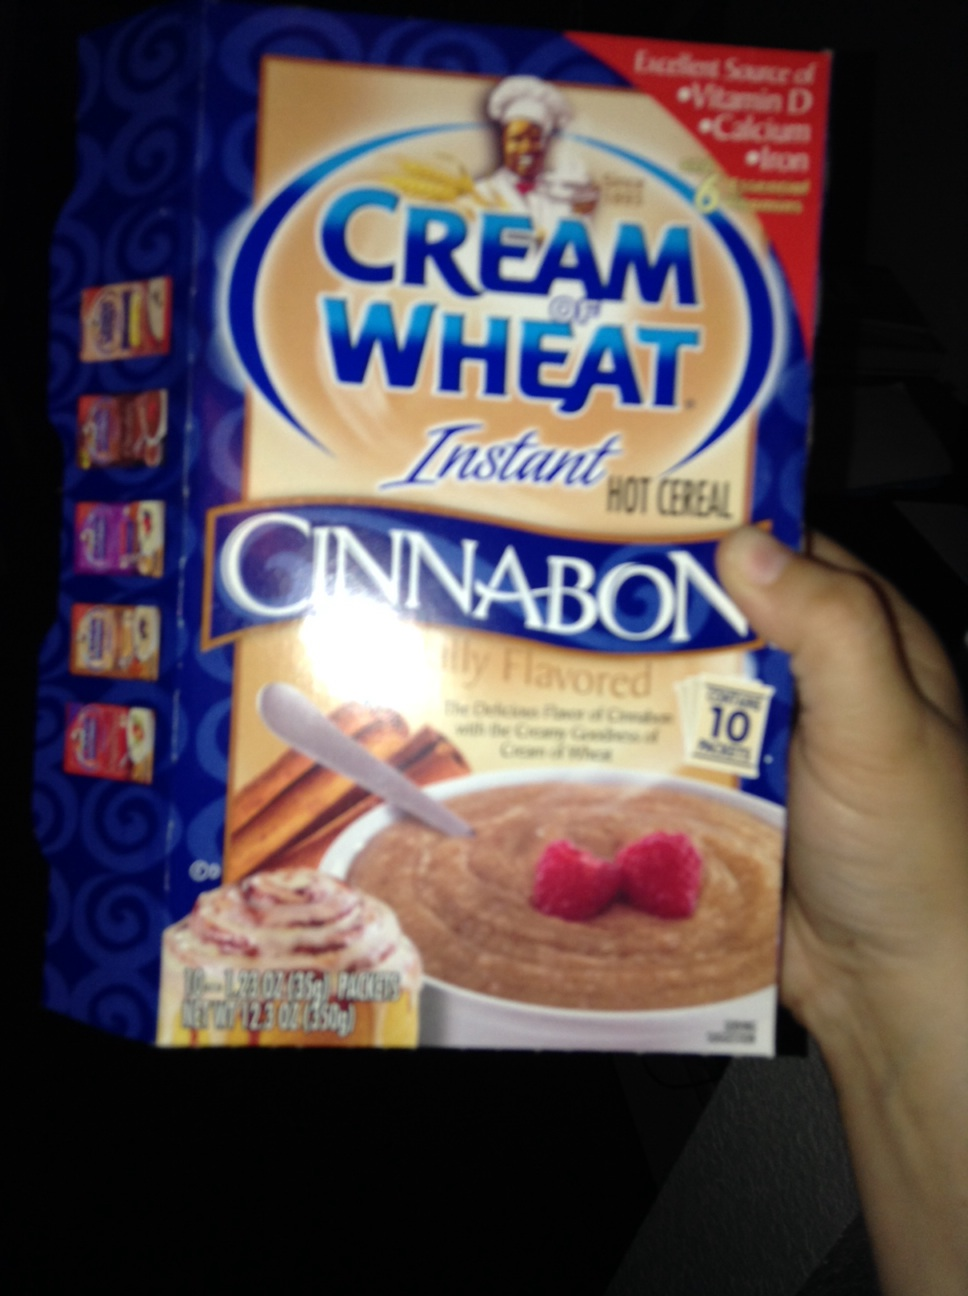What are the nutrition facts mentioned on this Cream of Wheat box? The box illustrates that this Cream of Wheat is an 'Excellent Source of Vitamin D, Calcium & Iron,' enhancing its nutritional profile. 